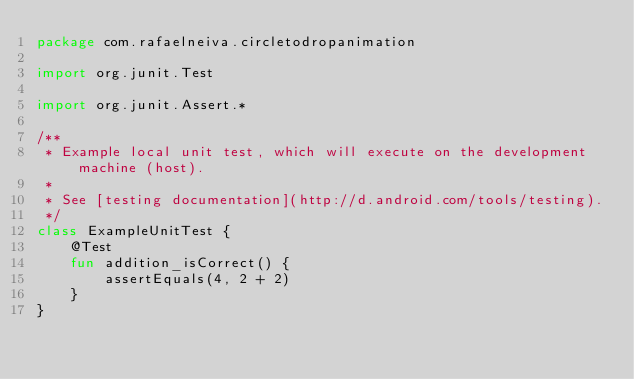Convert code to text. <code><loc_0><loc_0><loc_500><loc_500><_Kotlin_>package com.rafaelneiva.circletodropanimation

import org.junit.Test

import org.junit.Assert.*

/**
 * Example local unit test, which will execute on the development machine (host).
 *
 * See [testing documentation](http://d.android.com/tools/testing).
 */
class ExampleUnitTest {
    @Test
    fun addition_isCorrect() {
        assertEquals(4, 2 + 2)
    }
}
</code> 